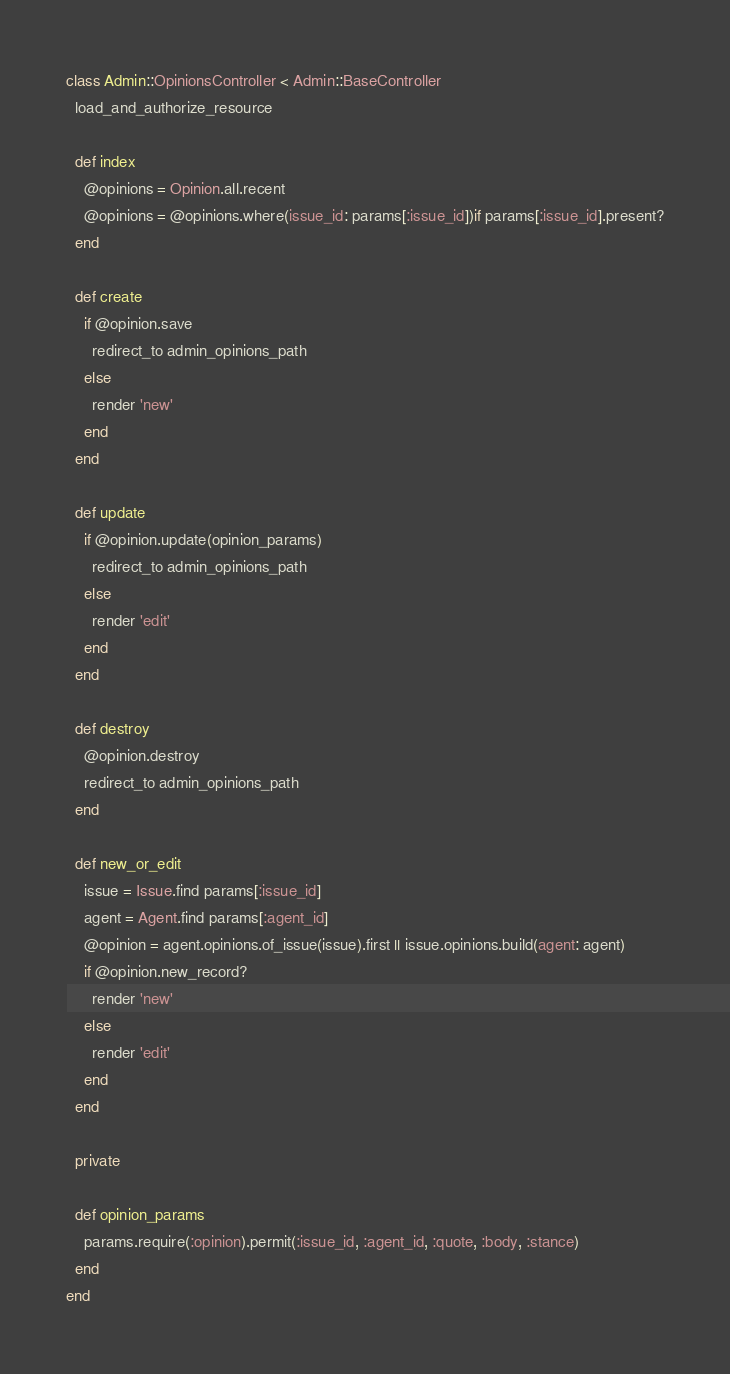<code> <loc_0><loc_0><loc_500><loc_500><_Ruby_>class Admin::OpinionsController < Admin::BaseController
  load_and_authorize_resource

  def index
    @opinions = Opinion.all.recent
    @opinions = @opinions.where(issue_id: params[:issue_id])if params[:issue_id].present?
  end

  def create
    if @opinion.save
      redirect_to admin_opinions_path
    else
      render 'new'
    end
  end

  def update
    if @opinion.update(opinion_params)
      redirect_to admin_opinions_path
    else
      render 'edit'
    end
  end

  def destroy
    @opinion.destroy
    redirect_to admin_opinions_path
  end

  def new_or_edit
    issue = Issue.find params[:issue_id]
    agent = Agent.find params[:agent_id]
    @opinion = agent.opinions.of_issue(issue).first || issue.opinions.build(agent: agent)
    if @opinion.new_record?
      render 'new'
    else
      render 'edit'
    end
  end

  private

  def opinion_params
    params.require(:opinion).permit(:issue_id, :agent_id, :quote, :body, :stance)
  end
end
</code> 